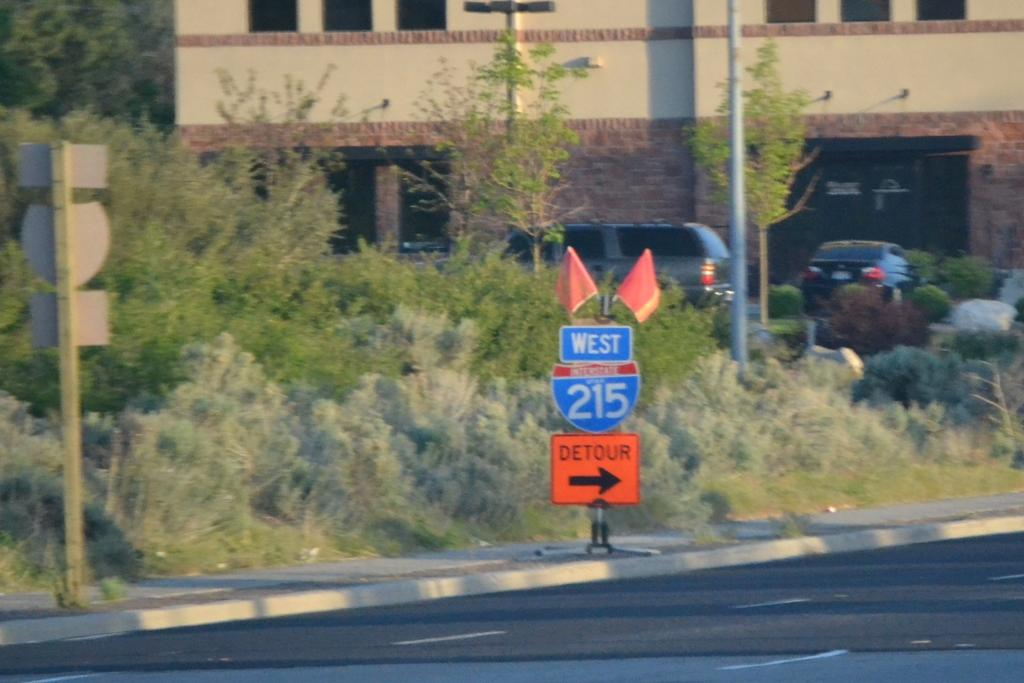<image>
Share a concise interpretation of the image provided. A road sign that shows a detour on to West 215. 